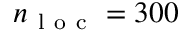<formula> <loc_0><loc_0><loc_500><loc_500>n _ { l o c } = 3 0 0</formula> 